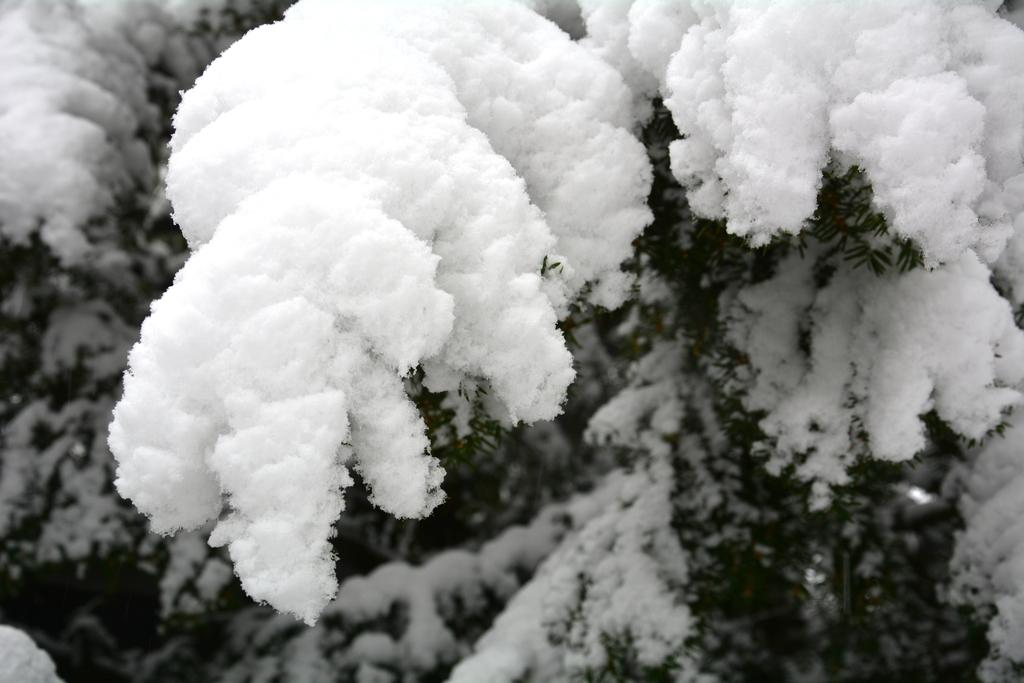What type of vegetation can be seen in the image? There are trees in the image. How are the trees in the image affected by the weather? The trees are covered with snow. What type of spark can be seen coming from the trees in the image? There is no spark present in the image; the trees are covered with snow. 